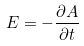Convert formula to latex. <formula><loc_0><loc_0><loc_500><loc_500>E = - \frac { \partial A } { \partial t }</formula> 